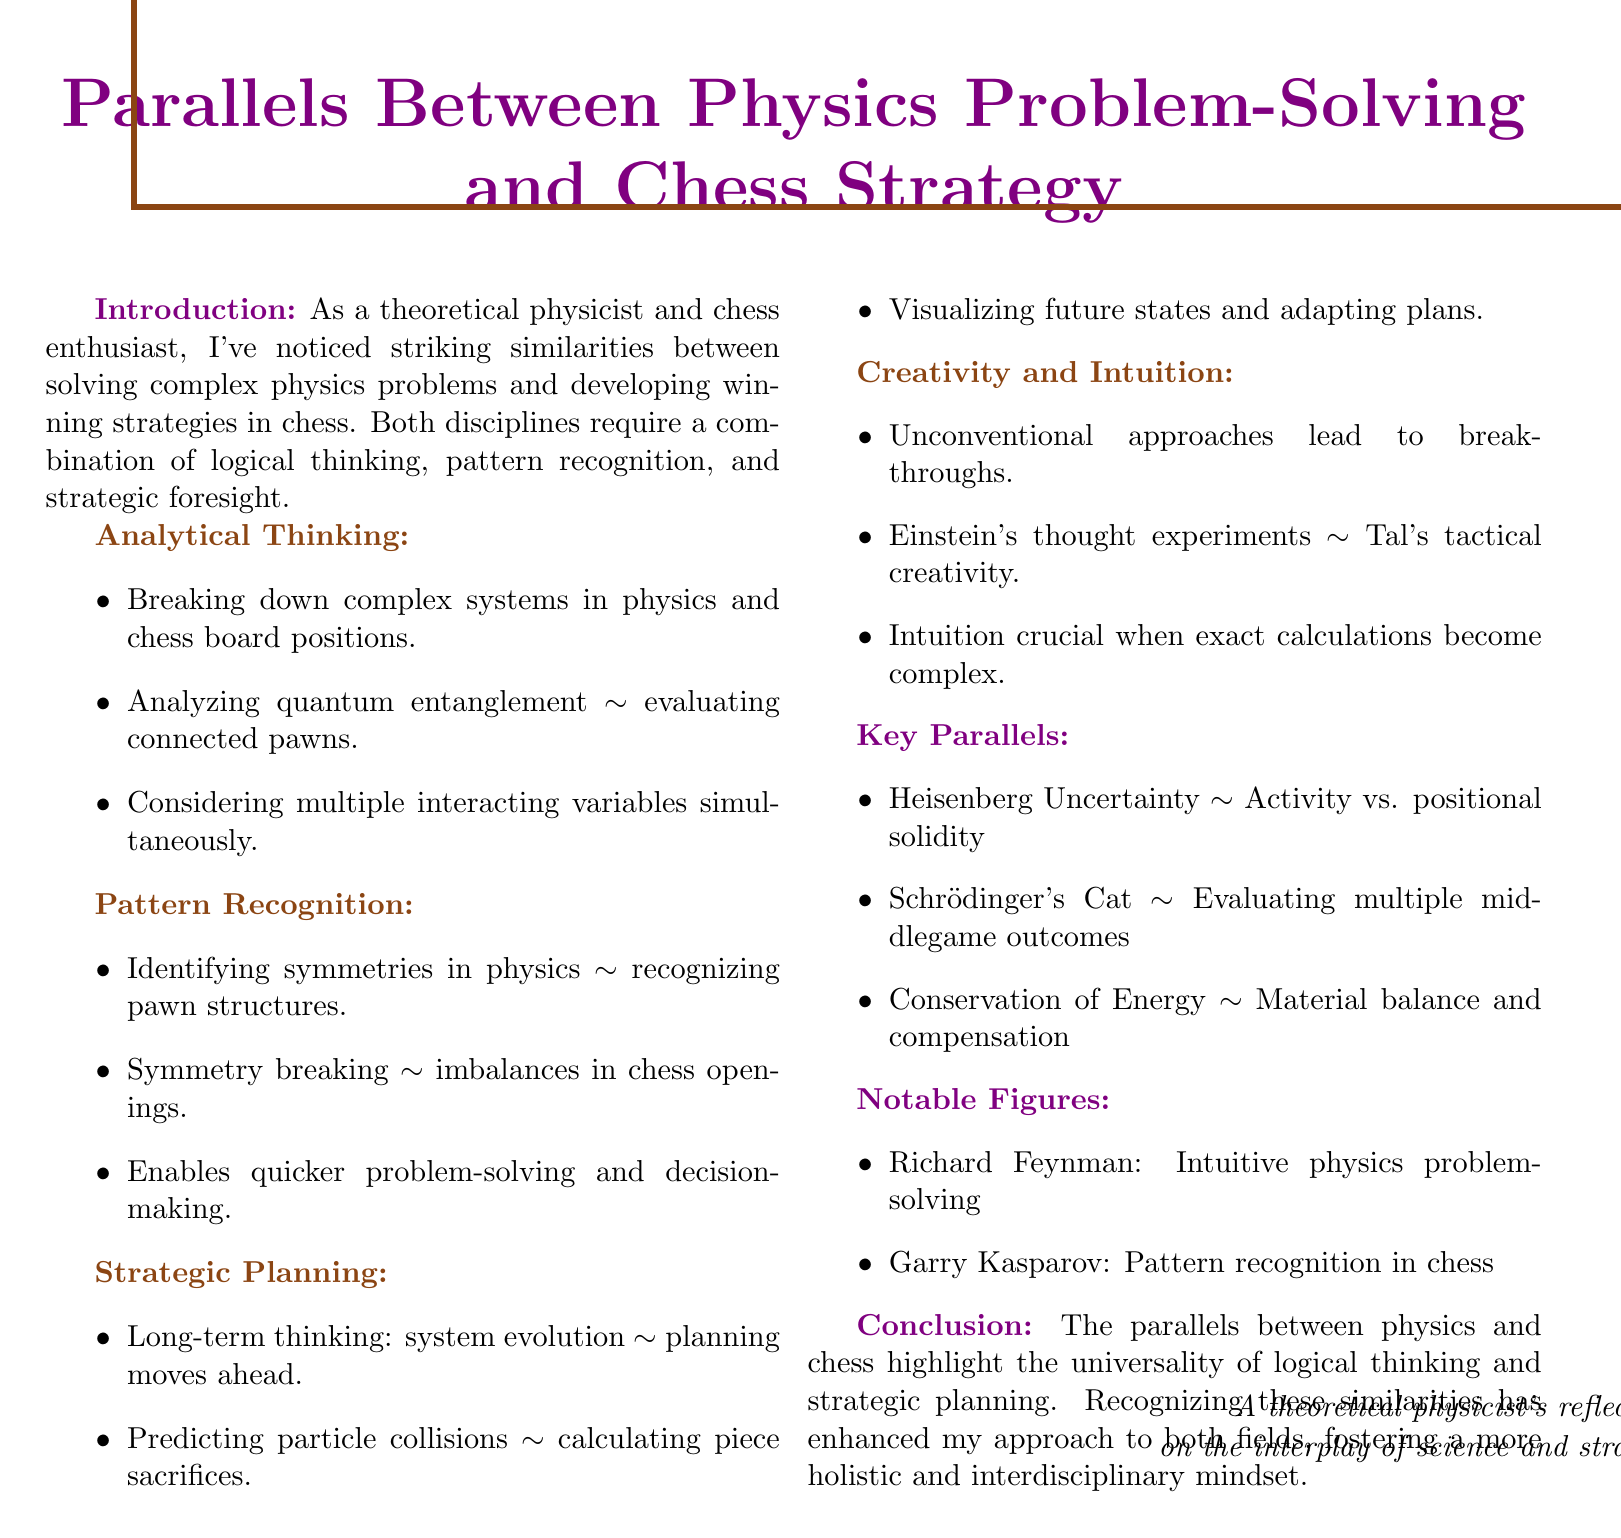What is the title of the document? The title is provided at the beginning of the memo and describes the main theme of the content.
Answer: Parallels Between Physics Problem-Solving and Chess Strategy What is discussed in the introduction? The introduction presents a personal observation about the similarities between two fields, setting the stage for the overall argument.
Answer: Similarities between solving complex physics problems and developing winning strategies in chess What concept is used to explain the importance of analytical thinking in both fields? The document highlights a comparison that exemplifies how analytical thinking is applied in both physics and chess.
Answer: Breaking down complex systems Which chess opening is mentioned as a parallel to symmetry breaking in particle physics? The document specifies an example that illustrates a strategic imbalance akin to a physics concept.
Answer: Sicilian Defense Who is noted for emphasizing pattern recognition in chess? The document refers to a notable figure in chess who is associated with the skills needed in both domains.
Answer: Garry Kasparov What principle is likened to the trade-off in chess openings? The relevant example connects a physical concept to a strategic chess consideration.
Answer: Heisenberg Uncertainty Principle What does the conclusion highlight regarding logical thinking and strategic planning? The conclusion summarizes the overall findings and implications drawn from the memo's content.
Answer: Universality of logical thinking and strategic planning Which physicist is mentioned for their intuitive approach to solving problems? The document lists notable figures related to the themes of physics and chess throughout the text.
Answer: Richard Feynman 